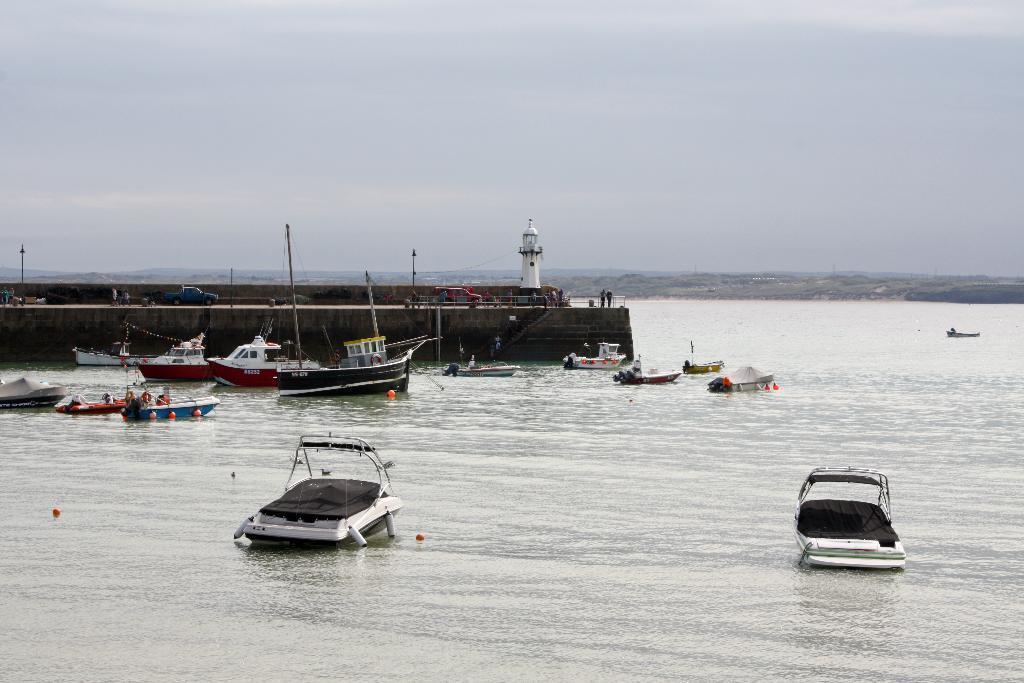Could you give a brief overview of what you see in this image? There are boats and ships on the water surface in the foreground, it seems like a bridge, tower, poles, trees and the sky in the background. 